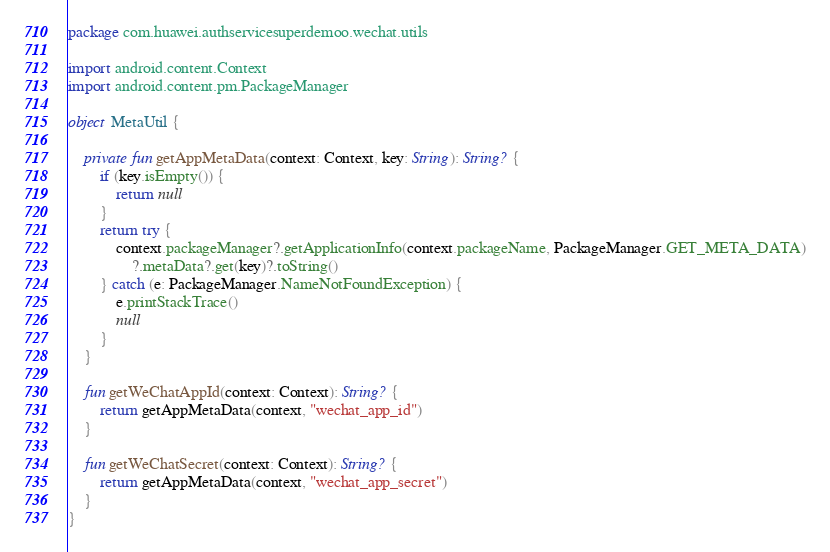<code> <loc_0><loc_0><loc_500><loc_500><_Kotlin_>package com.huawei.authservicesuperdemoo.wechat.utils

import android.content.Context
import android.content.pm.PackageManager

object MetaUtil {

    private fun getAppMetaData(context: Context, key: String): String? {
        if (key.isEmpty()) {
            return null
        }
        return try {
            context.packageManager?.getApplicationInfo(context.packageName, PackageManager.GET_META_DATA)
                ?.metaData?.get(key)?.toString()
        } catch (e: PackageManager.NameNotFoundException) {
            e.printStackTrace()
            null
        }
    }

    fun getWeChatAppId(context: Context): String? {
        return getAppMetaData(context, "wechat_app_id")
    }

    fun getWeChatSecret(context: Context): String? {
        return getAppMetaData(context, "wechat_app_secret")
    }
}</code> 